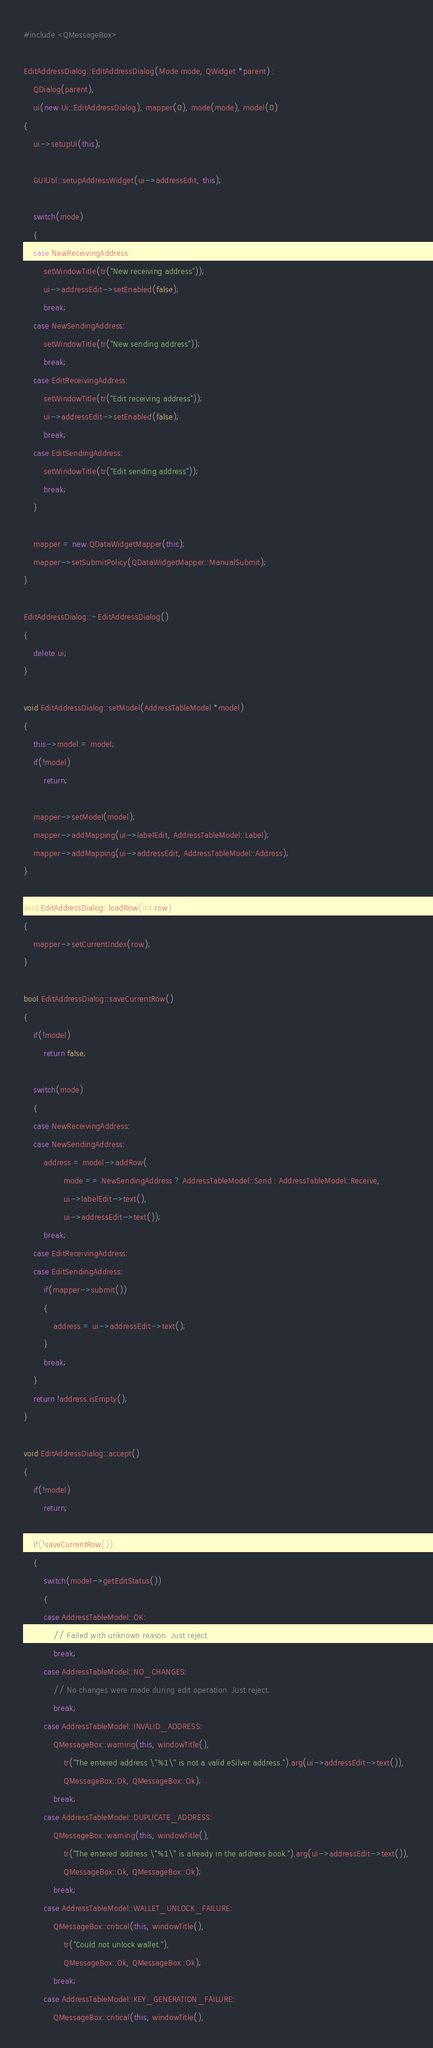Convert code to text. <code><loc_0><loc_0><loc_500><loc_500><_C++_>#include <QMessageBox>

EditAddressDialog::EditAddressDialog(Mode mode, QWidget *parent) :
    QDialog(parent),
    ui(new Ui::EditAddressDialog), mapper(0), mode(mode), model(0)
{
    ui->setupUi(this);

    GUIUtil::setupAddressWidget(ui->addressEdit, this);

    switch(mode)
    {
    case NewReceivingAddress:
        setWindowTitle(tr("New receiving address"));
        ui->addressEdit->setEnabled(false);
        break;
    case NewSendingAddress:
        setWindowTitle(tr("New sending address"));
        break;
    case EditReceivingAddress:
        setWindowTitle(tr("Edit receiving address"));
        ui->addressEdit->setEnabled(false);
        break;
    case EditSendingAddress:
        setWindowTitle(tr("Edit sending address"));
        break;
    }

    mapper = new QDataWidgetMapper(this);
    mapper->setSubmitPolicy(QDataWidgetMapper::ManualSubmit);
}

EditAddressDialog::~EditAddressDialog()
{
    delete ui;
}

void EditAddressDialog::setModel(AddressTableModel *model)
{
    this->model = model;
    if(!model)
        return;

    mapper->setModel(model);
    mapper->addMapping(ui->labelEdit, AddressTableModel::Label);
    mapper->addMapping(ui->addressEdit, AddressTableModel::Address);
}

void EditAddressDialog::loadRow(int row)
{
    mapper->setCurrentIndex(row);
}

bool EditAddressDialog::saveCurrentRow()
{
    if(!model)
        return false;

    switch(mode)
    {
    case NewReceivingAddress:
    case NewSendingAddress:
        address = model->addRow(
                mode == NewSendingAddress ? AddressTableModel::Send : AddressTableModel::Receive,
                ui->labelEdit->text(),
                ui->addressEdit->text());
        break;
    case EditReceivingAddress:
    case EditSendingAddress:
        if(mapper->submit())
        {
            address = ui->addressEdit->text();
        }
        break;
    }
    return !address.isEmpty();
}

void EditAddressDialog::accept()
{
    if(!model)
        return;

    if(!saveCurrentRow())
    {
        switch(model->getEditStatus())
        {
        case AddressTableModel::OK:
            // Failed with unknown reason. Just reject.
            break;
        case AddressTableModel::NO_CHANGES:
            // No changes were made during edit operation. Just reject.
            break;
        case AddressTableModel::INVALID_ADDRESS:
            QMessageBox::warning(this, windowTitle(),
                tr("The entered address \"%1\" is not a valid eSilver address.").arg(ui->addressEdit->text()),
                QMessageBox::Ok, QMessageBox::Ok);
            break;
        case AddressTableModel::DUPLICATE_ADDRESS:
            QMessageBox::warning(this, windowTitle(),
                tr("The entered address \"%1\" is already in the address book.").arg(ui->addressEdit->text()),
                QMessageBox::Ok, QMessageBox::Ok);
            break;
        case AddressTableModel::WALLET_UNLOCK_FAILURE:
            QMessageBox::critical(this, windowTitle(),
                tr("Could not unlock wallet."),
                QMessageBox::Ok, QMessageBox::Ok);
            break;
        case AddressTableModel::KEY_GENERATION_FAILURE:
            QMessageBox::critical(this, windowTitle(),</code> 